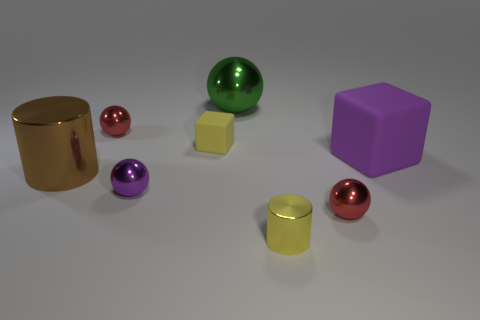How big is the red shiny sphere that is left of the red ball that is in front of the red object left of the green thing?
Your answer should be very brief. Small. What number of large green metal objects are right of the large cylinder?
Provide a short and direct response. 1. Are there more big green shiny spheres than objects?
Your answer should be very brief. No. What is the size of the metallic ball that is the same color as the large matte block?
Offer a very short reply. Small. How big is the shiny thing that is in front of the purple sphere and behind the tiny metal cylinder?
Make the answer very short. Small. The cylinder that is in front of the red sphere that is in front of the tiny ball that is behind the large matte block is made of what material?
Keep it short and to the point. Metal. There is a cylinder that is the same color as the tiny cube; what is its material?
Ensure brevity in your answer.  Metal. Do the large thing on the right side of the yellow metal thing and the cube that is on the left side of the big shiny sphere have the same color?
Make the answer very short. No. There is a yellow object on the right side of the rubber cube on the left side of the large shiny object right of the large cylinder; what is its shape?
Offer a terse response. Cylinder. There is a tiny shiny thing that is in front of the tiny block and to the left of the big metallic sphere; what shape is it?
Offer a very short reply. Sphere. 